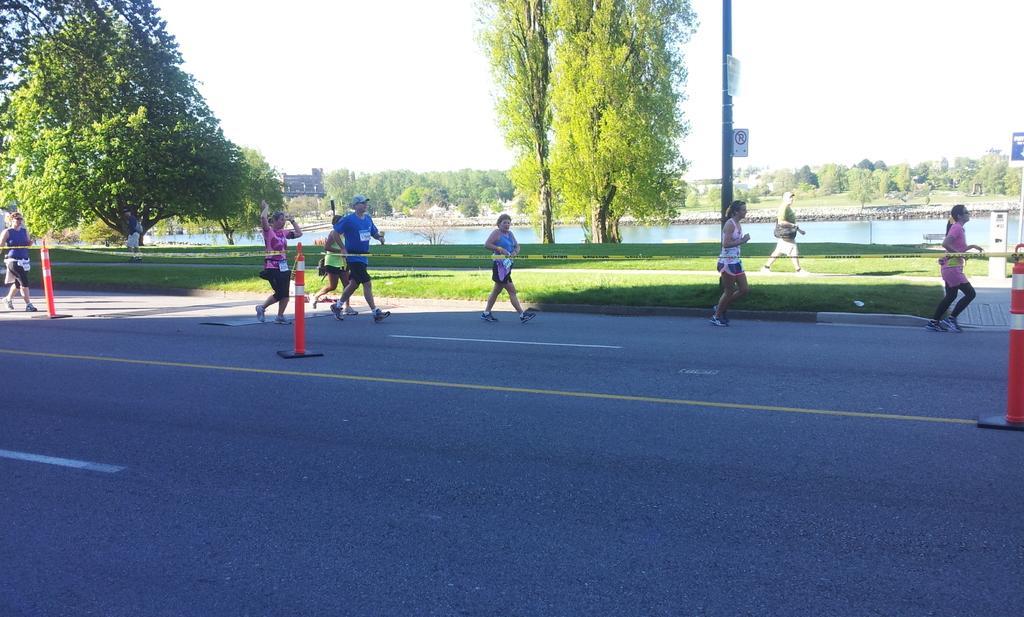Could you give a brief overview of what you see in this image? In this image we can see some people running on the road and there are barricades on the road. To the side, we can see a pavement on which a few people are walking and there are trees and the water. At the top we can see the sky. 